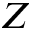Convert formula to latex. <formula><loc_0><loc_0><loc_500><loc_500>Z</formula> 